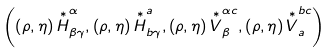Convert formula to latex. <formula><loc_0><loc_0><loc_500><loc_500>\left ( \left ( \rho , \eta \right ) \overset { \ast } { H } _ { \beta \gamma } ^ { \alpha } , \left ( \rho , \eta \right ) \overset { \ast } { H } _ { b \gamma } ^ { a } , \left ( \rho , \eta \right ) \overset { \ast } { V } _ { \beta } ^ { \alpha c } , \left ( \rho , \eta \right ) \overset { \ast } { V } _ { a } ^ { b c } \right )</formula> 